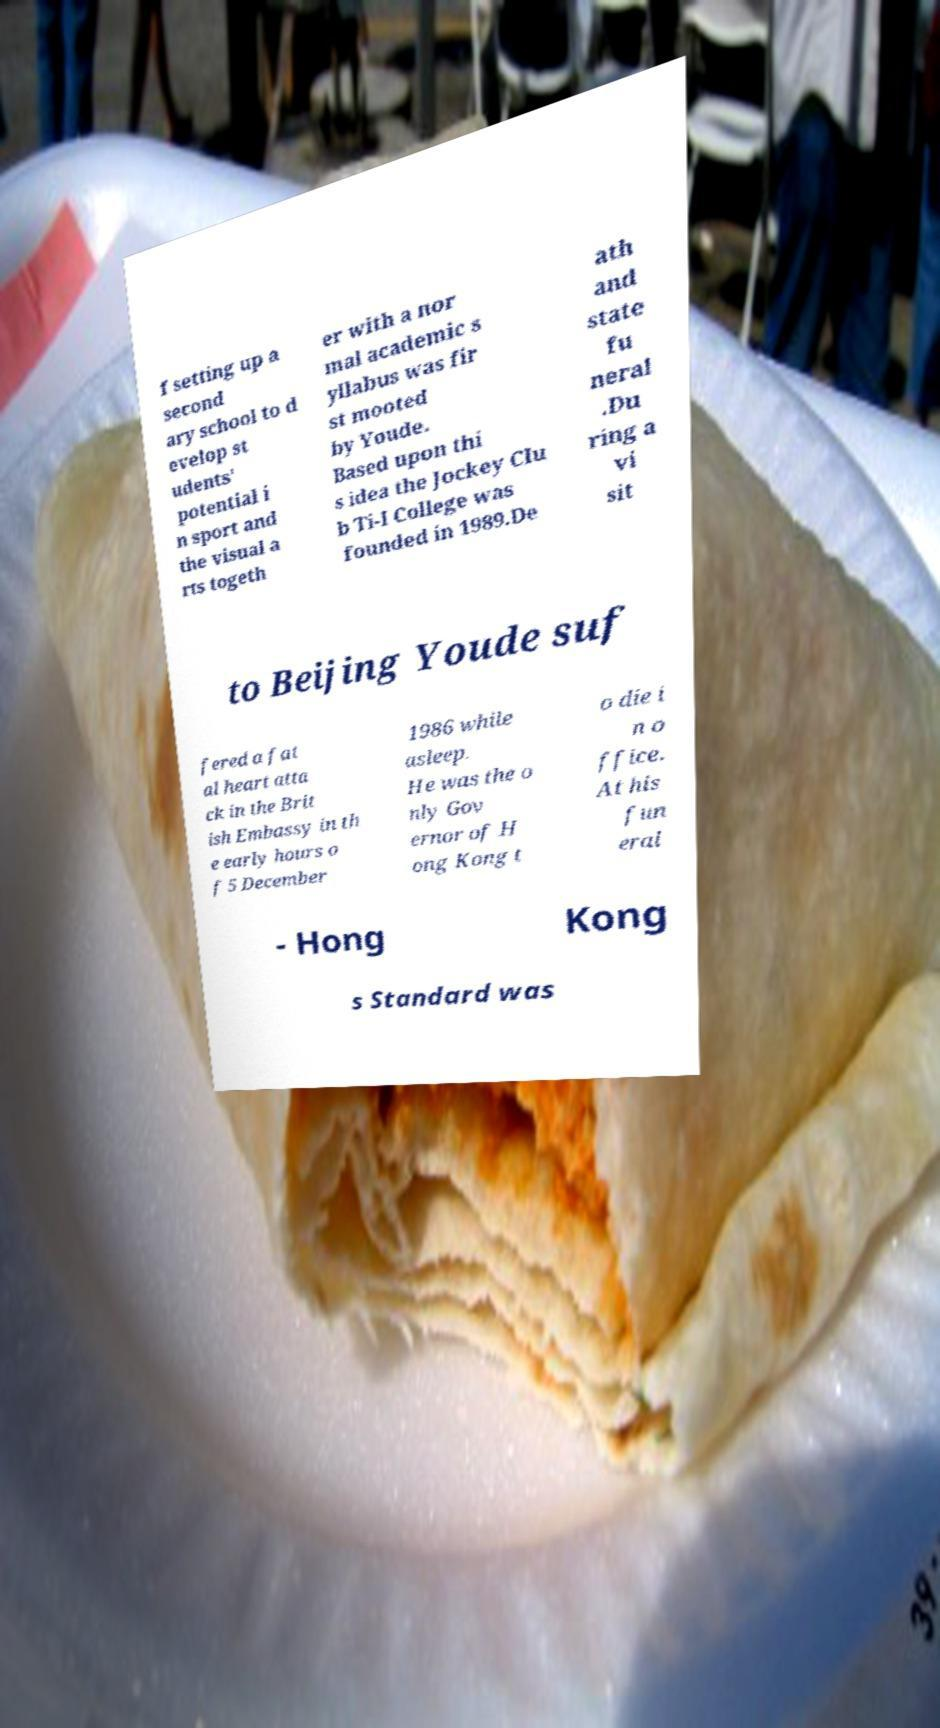Could you assist in decoding the text presented in this image and type it out clearly? f setting up a second ary school to d evelop st udents' potential i n sport and the visual a rts togeth er with a nor mal academic s yllabus was fir st mooted by Youde. Based upon thi s idea the Jockey Clu b Ti-I College was founded in 1989.De ath and state fu neral .Du ring a vi sit to Beijing Youde suf fered a fat al heart atta ck in the Brit ish Embassy in th e early hours o f 5 December 1986 while asleep. He was the o nly Gov ernor of H ong Kong t o die i n o ffice. At his fun eral - Hong Kong s Standard was 